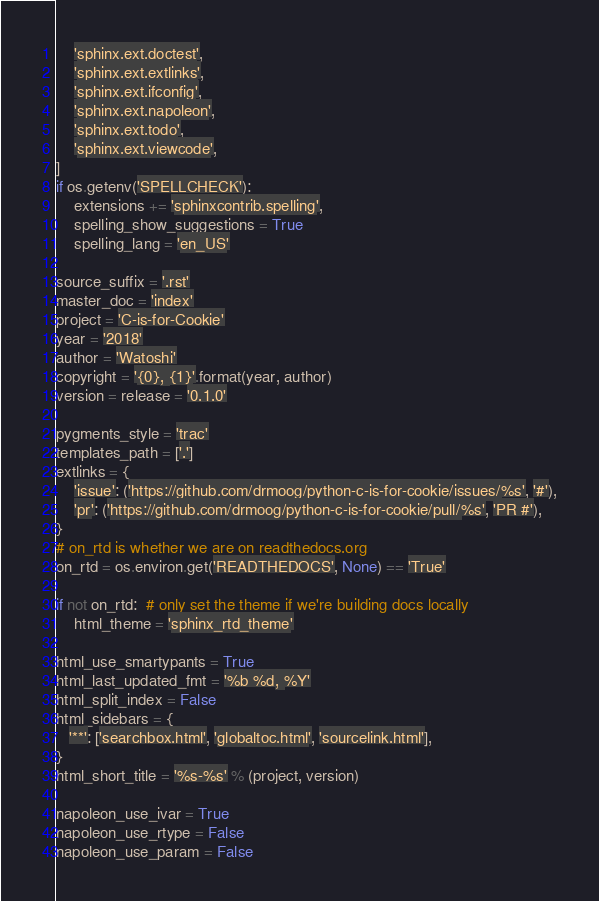<code> <loc_0><loc_0><loc_500><loc_500><_Python_>    'sphinx.ext.doctest',
    'sphinx.ext.extlinks',
    'sphinx.ext.ifconfig',
    'sphinx.ext.napoleon',
    'sphinx.ext.todo',
    'sphinx.ext.viewcode',
]
if os.getenv('SPELLCHECK'):
    extensions += 'sphinxcontrib.spelling',
    spelling_show_suggestions = True
    spelling_lang = 'en_US'

source_suffix = '.rst'
master_doc = 'index'
project = 'C-is-for-Cookie'
year = '2018'
author = 'Watoshi'
copyright = '{0}, {1}'.format(year, author)
version = release = '0.1.0'

pygments_style = 'trac'
templates_path = ['.']
extlinks = {
    'issue': ('https://github.com/drmoog/python-c-is-for-cookie/issues/%s', '#'),
    'pr': ('https://github.com/drmoog/python-c-is-for-cookie/pull/%s', 'PR #'),
}
# on_rtd is whether we are on readthedocs.org
on_rtd = os.environ.get('READTHEDOCS', None) == 'True'

if not on_rtd:  # only set the theme if we're building docs locally
    html_theme = 'sphinx_rtd_theme'

html_use_smartypants = True
html_last_updated_fmt = '%b %d, %Y'
html_split_index = False
html_sidebars = {
   '**': ['searchbox.html', 'globaltoc.html', 'sourcelink.html'],
}
html_short_title = '%s-%s' % (project, version)

napoleon_use_ivar = True
napoleon_use_rtype = False
napoleon_use_param = False
</code> 